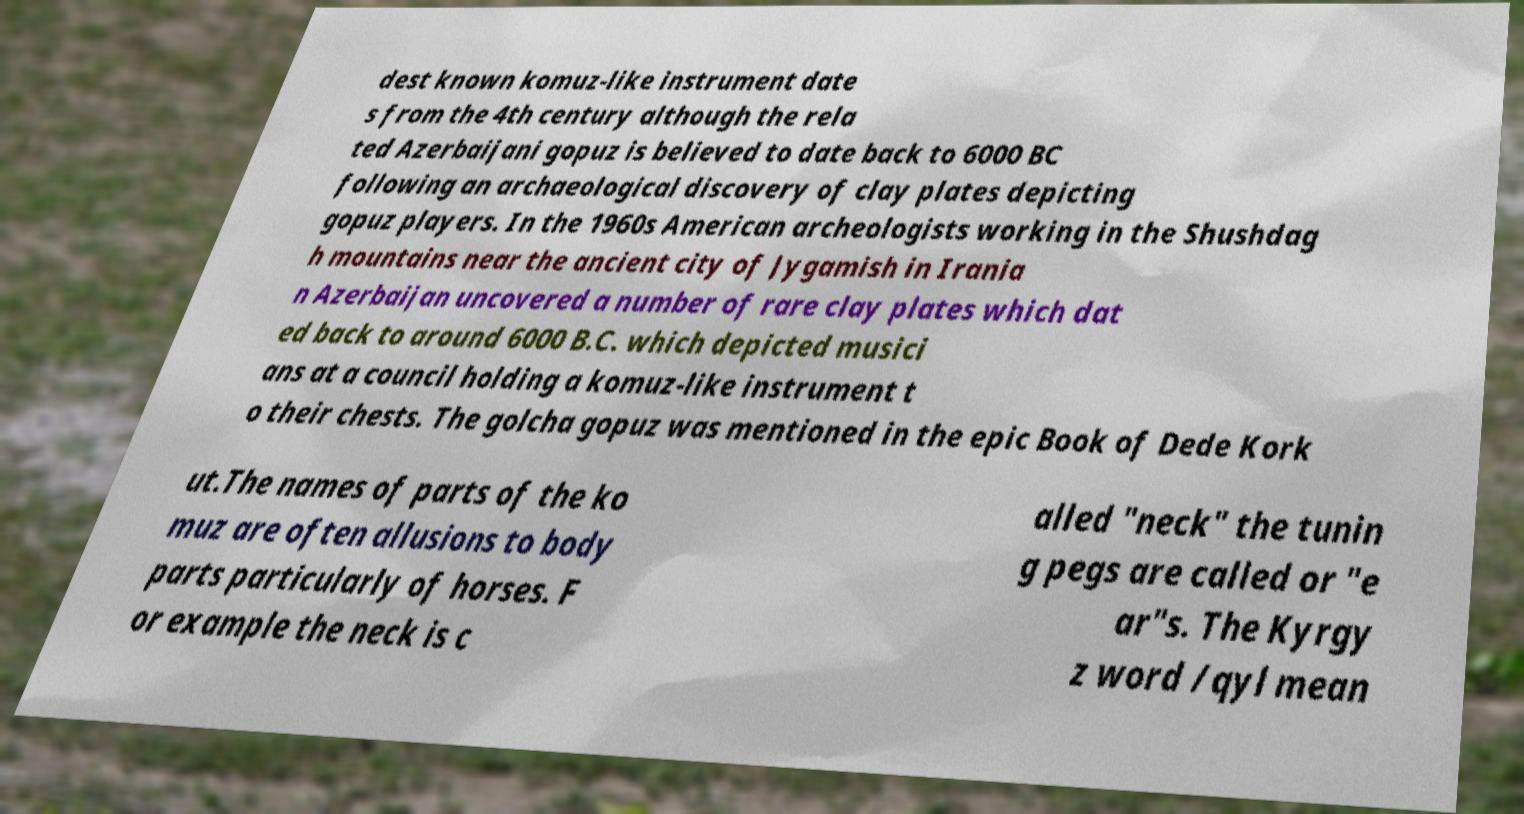For documentation purposes, I need the text within this image transcribed. Could you provide that? dest known komuz-like instrument date s from the 4th century although the rela ted Azerbaijani gopuz is believed to date back to 6000 BC following an archaeological discovery of clay plates depicting gopuz players. In the 1960s American archeologists working in the Shushdag h mountains near the ancient city of Jygamish in Irania n Azerbaijan uncovered a number of rare clay plates which dat ed back to around 6000 B.C. which depicted musici ans at a council holding a komuz-like instrument t o their chests. The golcha gopuz was mentioned in the epic Book of Dede Kork ut.The names of parts of the ko muz are often allusions to body parts particularly of horses. F or example the neck is c alled "neck" the tunin g pegs are called or "e ar"s. The Kyrgy z word /qyl mean 